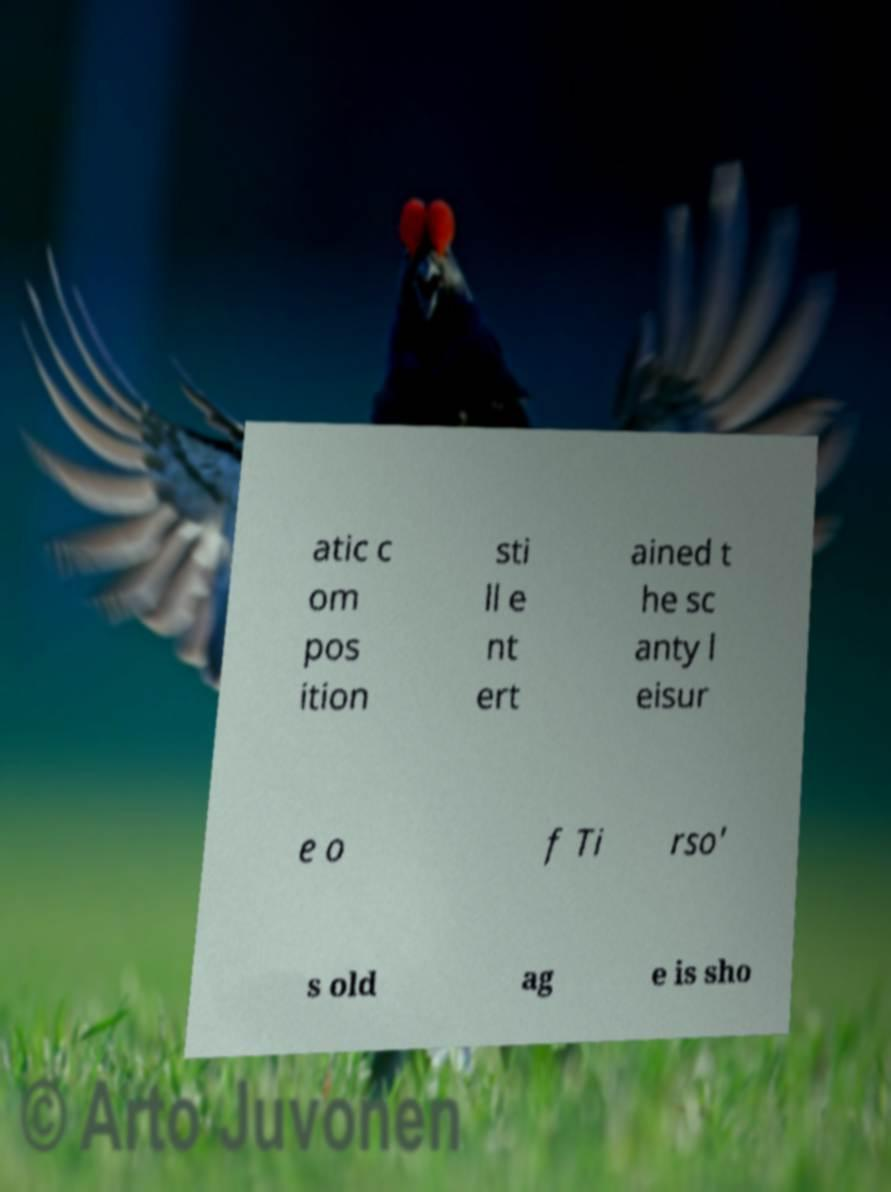Can you read and provide the text displayed in the image?This photo seems to have some interesting text. Can you extract and type it out for me? atic c om pos ition sti ll e nt ert ained t he sc anty l eisur e o f Ti rso' s old ag e is sho 